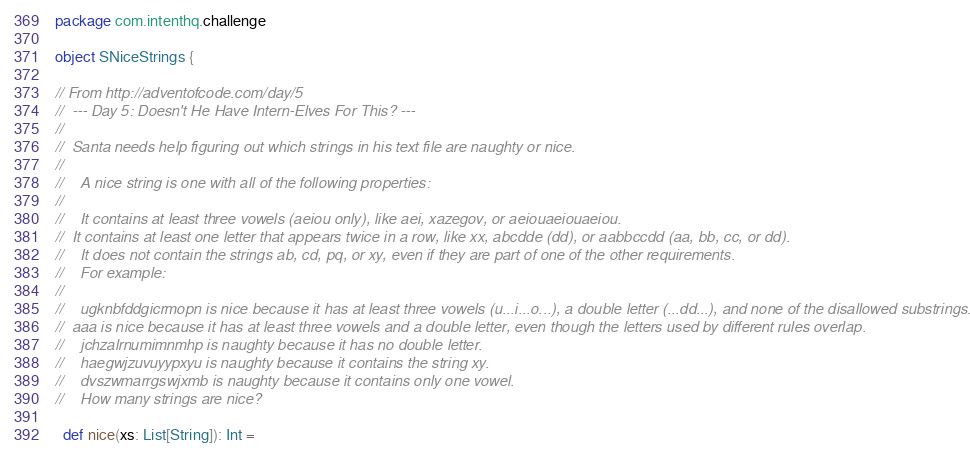<code> <loc_0><loc_0><loc_500><loc_500><_Scala_>package com.intenthq.challenge

object SNiceStrings {

// From http://adventofcode.com/day/5
//  --- Day 5: Doesn't He Have Intern-Elves For This? ---
//
//  Santa needs help figuring out which strings in his text file are naughty or nice.
//
//    A nice string is one with all of the following properties:
//
//    It contains at least three vowels (aeiou only), like aei, xazegov, or aeiouaeiouaeiou.
//  It contains at least one letter that appears twice in a row, like xx, abcdde (dd), or aabbccdd (aa, bb, cc, or dd).
//    It does not contain the strings ab, cd, pq, or xy, even if they are part of one of the other requirements.
//    For example:
//
//    ugknbfddgicrmopn is nice because it has at least three vowels (u...i...o...), a double letter (...dd...), and none of the disallowed substrings.
//  aaa is nice because it has at least three vowels and a double letter, even though the letters used by different rules overlap.
//    jchzalrnumimnmhp is naughty because it has no double letter.
//    haegwjzuvuyypxyu is naughty because it contains the string xy.
//    dvszwmarrgswjxmb is naughty because it contains only one vowel.
//    How many strings are nice?

  def nice(xs: List[String]): Int =</code> 